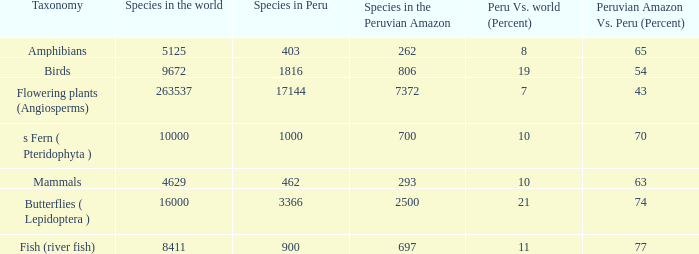What's the minimum species in the peruvian amazon with species in peru of 1000 700.0. Write the full table. {'header': ['Taxonomy', 'Species in the world', 'Species in Peru', 'Species in the Peruvian Amazon', 'Peru Vs. world (Percent)', 'Peruvian Amazon Vs. Peru (Percent)'], 'rows': [['Amphibians', '5125', '403', '262', '8', '65'], ['Birds', '9672', '1816', '806', '19', '54'], ['Flowering plants (Angiosperms)', '263537', '17144', '7372', '7', '43'], ['s Fern ( Pteridophyta )', '10000', '1000', '700', '10', '70'], ['Mammals', '4629', '462', '293', '10', '63'], ['Butterflies ( Lepidoptera )', '16000', '3366', '2500', '21', '74'], ['Fish (river fish)', '8411', '900', '697', '11', '77']]} 